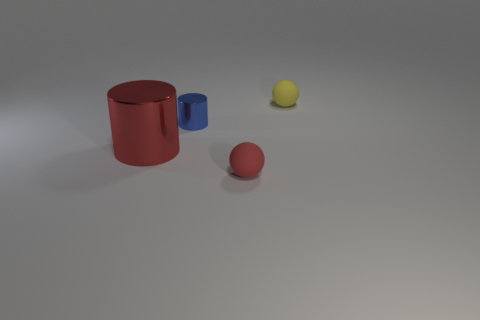Add 2 large rubber cylinders. How many objects exist? 6 Subtract all yellow spheres. How many spheres are left? 1 Subtract 0 blue spheres. How many objects are left? 4 Subtract 1 spheres. How many spheres are left? 1 Subtract all brown spheres. Subtract all gray blocks. How many spheres are left? 2 Subtract all gray cylinders. How many blue spheres are left? 0 Subtract all small yellow rubber things. Subtract all big things. How many objects are left? 2 Add 4 tiny blue metal things. How many tiny blue metal things are left? 5 Add 3 tiny cyan rubber blocks. How many tiny cyan rubber blocks exist? 3 